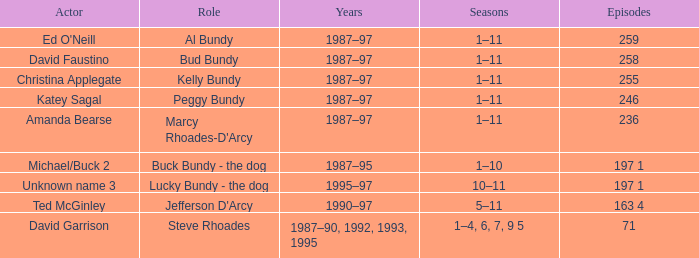How many years did the role of Steve Rhoades last? 1987–90, 1992, 1993, 1995. 